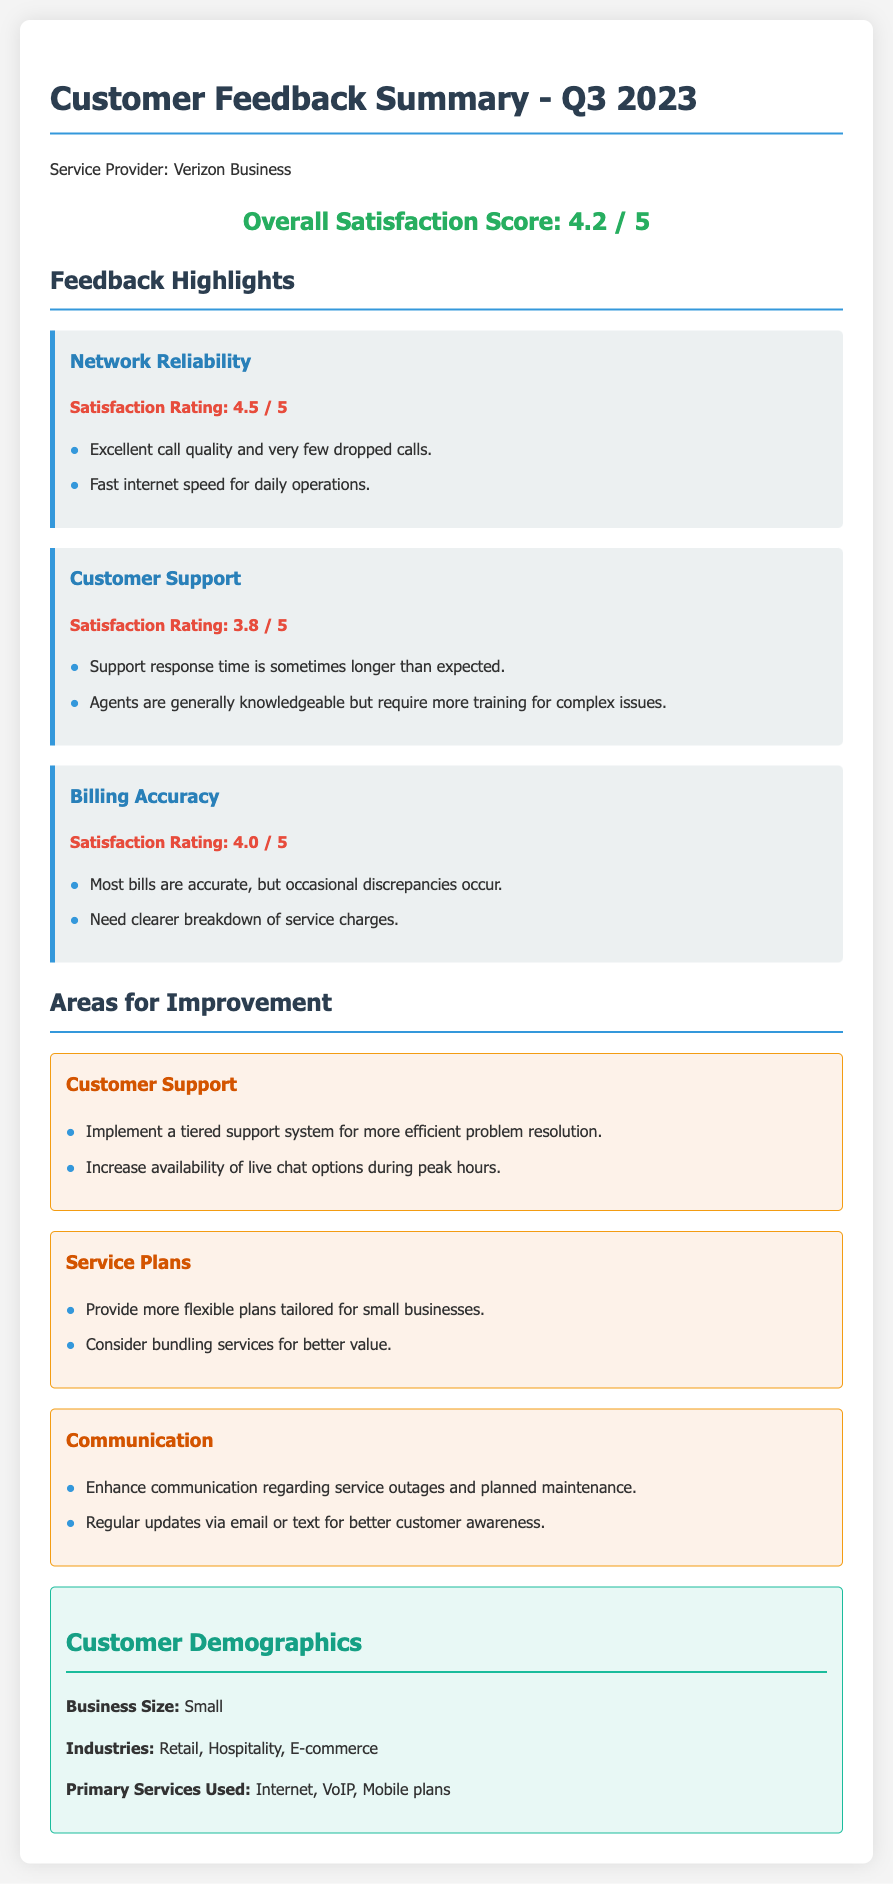What is the overall satisfaction score? The overall satisfaction score is provided in the feedback summary as an indicator of customer satisfaction with the service.
Answer: 4.2 / 5 What is the satisfaction rating for network reliability? The satisfaction rating for network reliability is a measure of how customers feel about the quality and performance of the network.
Answer: 4.5 / 5 What are two key issues in customer support mentioned? The document lists specific aspects of customer support that need improvement, highlighting particular concerns raised by customers.
Answer: Longer response time, need for more training Which area had the highest satisfaction rating? The document highlights multiple satisfaction ratings, and identifying the highest allows understanding of the service aspect performing best.
Answer: Network Reliability What improvements are suggested for communication? Suggestions for improvement often point towards enhancing customer experience, particularly in how updates and notifications are managed.
Answer: Enhance communication, regular updates What services are primarily used by customers? The summarized demographics section outlines the main services clients utilize, which helps tailor offerings to their needs.
Answer: Internet, VoIP, Mobile plans Which improvement suggestion pertains to service plans? Improvement areas can guide the company in adjusting its product offerings to better meet customer demands and expectations.
Answer: Provide more flexible plans What is the satisfaction rating for customer support? Understanding customer satisfaction ratings across different areas helps gauge overall service quality and identify priorities for enhancement.
Answer: 3.8 / 5 